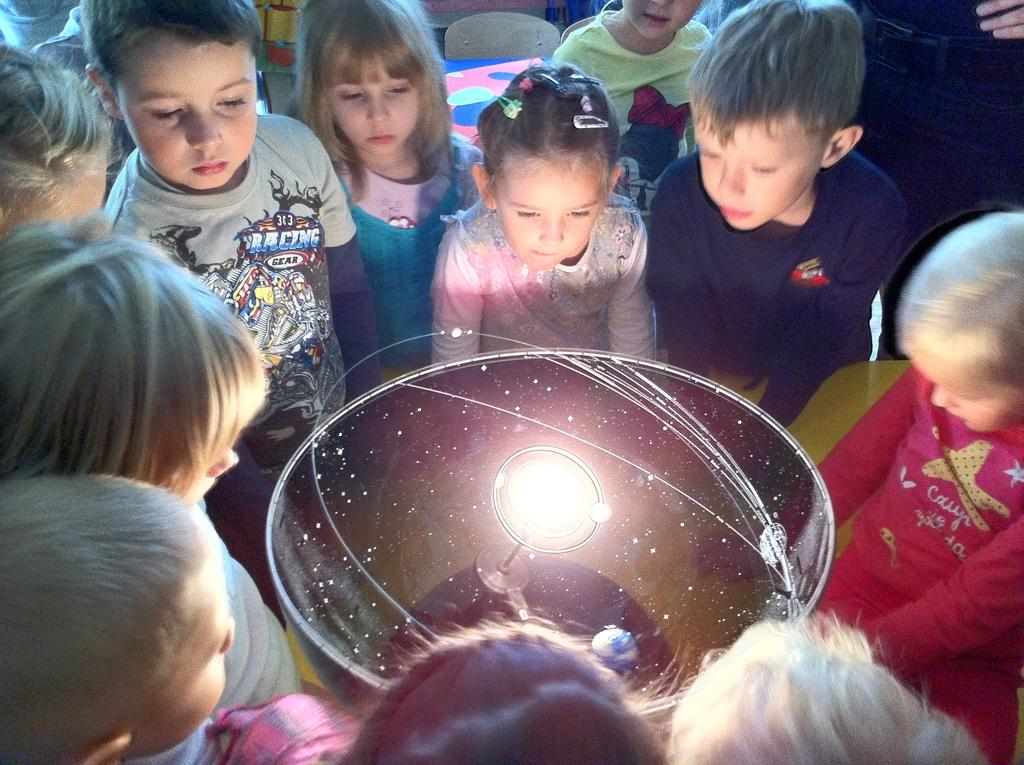What is the main object in the middle of the image? There is a light emitting object in the middle of the image. Who is present around the light emitting object? There are kids around the light emitting object. What can be seen in the background of the image? There is an object on a platform and a chair in the background of the image. What health advice is written on the note in the image? There is no note present in the image, so no health advice can be observed. How many women are visible in the image? There is no mention of women in the provided facts, so we cannot determine the number of women in the image. 